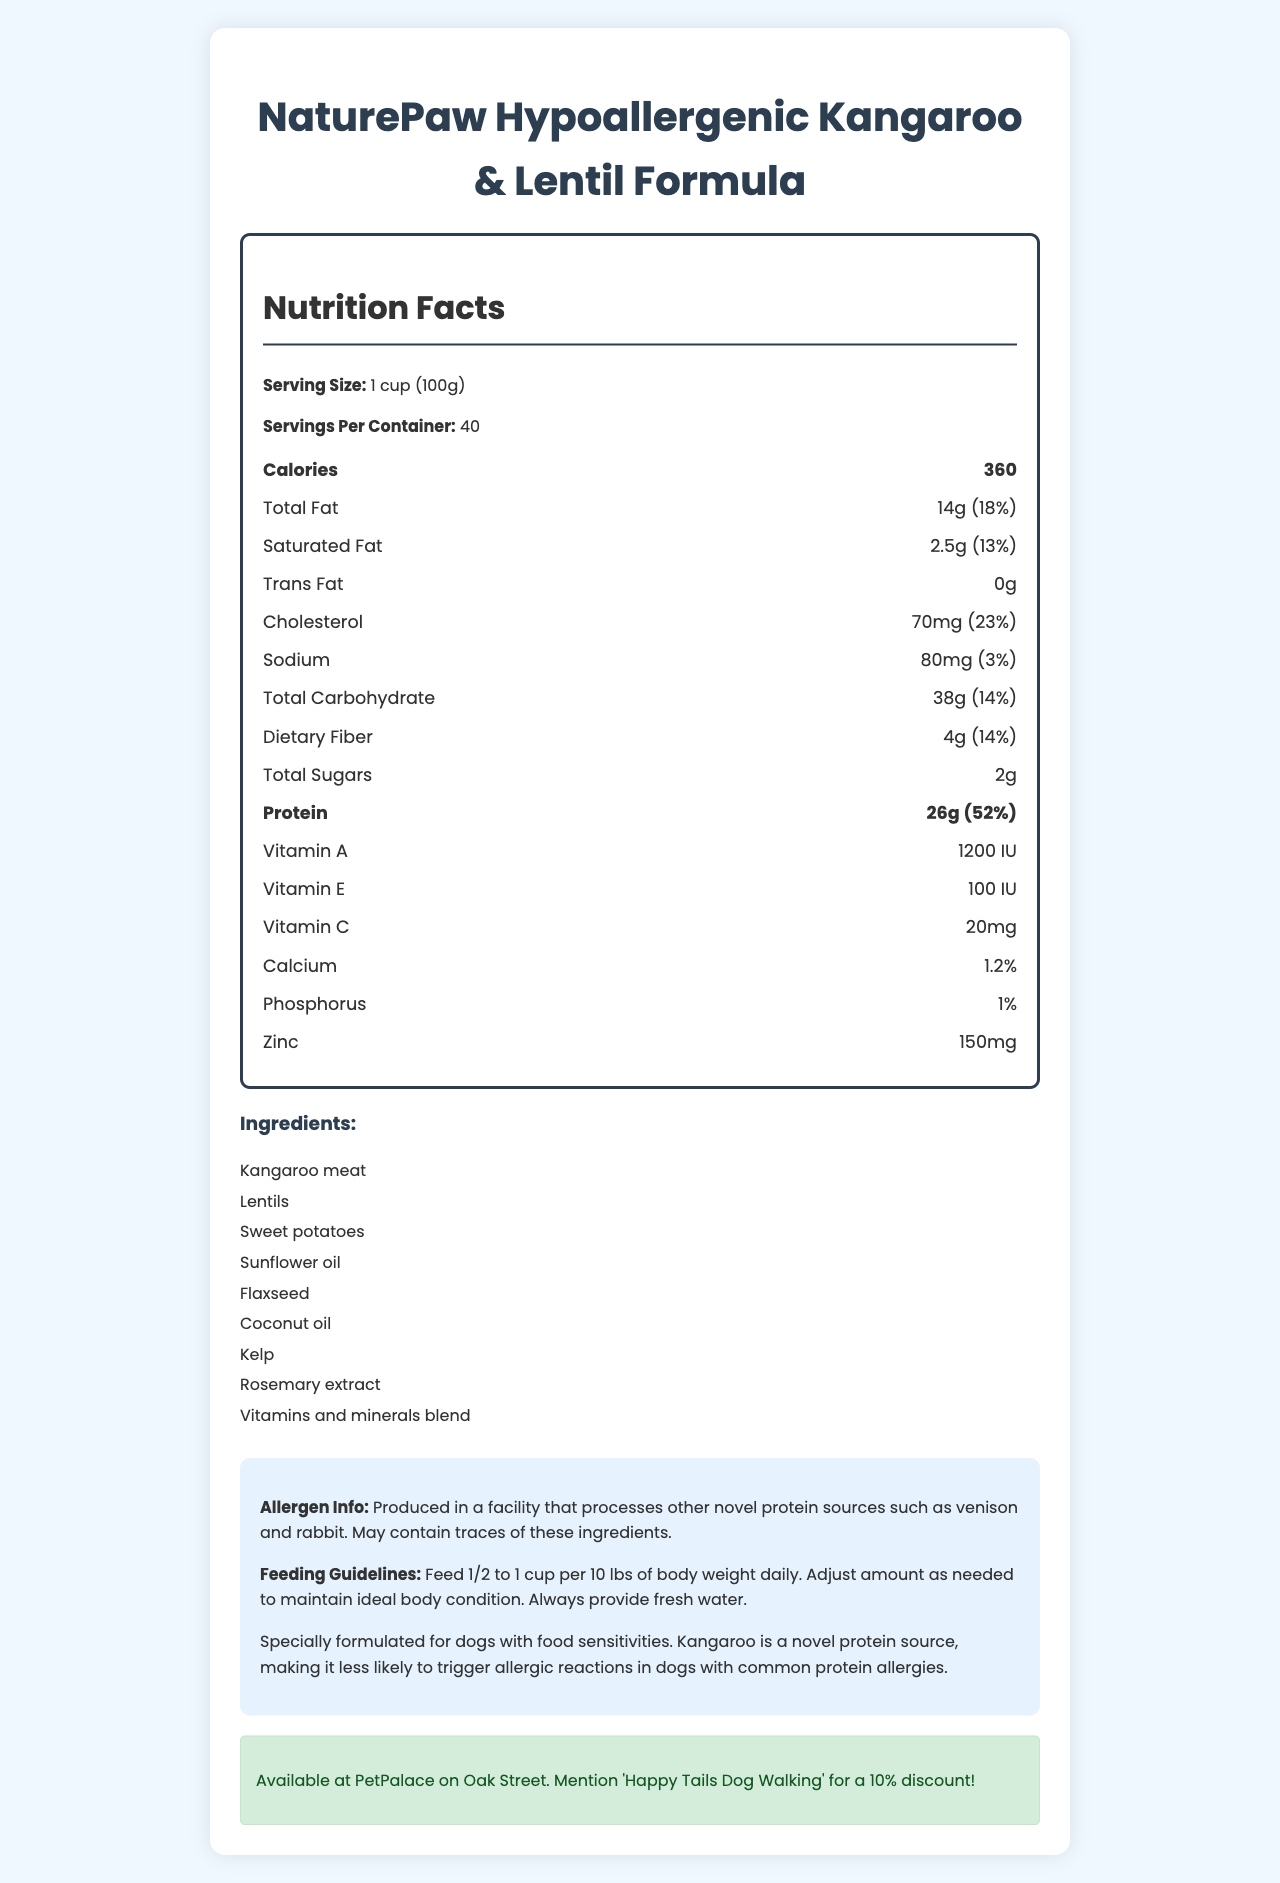what is the serving size for the dog food? The serving size is stated at the top of the nutrition facts section as "1 cup (100g)".
Answer: 1 cup (100g) how many servings are there in a container? The number of servings per container is indicated as 40, right below the serving size.
Answer: 40 how many calories are in one serving? The calorie count per serving is listed as "360" in the bolded section for calories.
Answer: 360 what is the amount of protein in one serving? The amount of protein per serving is listed as 26g in the nutrition facts.
Answer: 26g what are the main ingredients of the dog food? The main ingredients are listed under the ingredient section as: Kangaroo meat, Lentils, Sweet potatoes, Sunflower oil, Flaxseed, Coconut oil, Kelp, Rosemary extract, Vitamins and minerals blend.
Answer: Kangaroo meat, Lentils, Sweet potatoes, Sunflower oil, Flaxseed, Coconut oil, Kelp, Rosemary extract, Vitamins and minerals blend which vitamin is present in the highest amount? A. Vitamin A B. Vitamin C C. Vitamin E The visual information shows that Vitamin E is listed as 100 IU, which is higher than 1200 IU (Vitamin A) and 20mg (Vitamin C).
Answer: C. Vitamin E what percentage of daily value does the total fat represent? A. 10% B. 13% C. 18% D. 23% The total fat daily value is listed as 18%, which can be found next to 14g of total fat.
Answer: C. 18% are there any trans fats in the dog food? The nutrition label states "Trans Fat 0g", indicating there are no trans fats in the food.
Answer: No is the food suitable for dogs with common protein allergies? The additional information section states that it is specially formulated for dogs with food sensitivities and that kangaroo is a novel protein source, making it less likely to trigger allergic reactions in dogs with common protein allergies.
Answer: Yes summarize the overall information provided in the document. The document provides comprehensive nutritional details, ingredients, and feeding guidelines for the hypoallergenic dog food. It emphasizes its suitability for dogs with allergies and offers a discount at a specific pet shop.
Answer: The document is a nutrition facts label for NaturePaw Hypoallergenic Kangaroo & Lentil Formula dog food. It lists serving sizes, nutritional content such as calories, fats, cholesterol, protein, and vitamins. It also includes the ingredients, potential allergen information, feeding guidelines, and a shop recommendation. Special highlights mention the food's suitability for dogs with food sensitivities due to the use of novel protein sources like kangaroo. how much cholesterol is in one serving? The cholesterol content per serving is listed as 70mg.
Answer: 70mg what is the feeding recommendation for a dog weighing 20 lbs? Based on the feeding guidelines, the recommended amount is 1/2 to 1 cup per 10 lbs of body weight. Therefore, for a 20 lb dog, it would be 1 to 2 cups daily.
Answer: 1 to 2 cups daily where can you buy this dog food and get a discount? The document states that the dog food is available at PetPalace on Oak Street, with a 10% discount if you mention "Happy Tails Dog Walking".
Answer: PetPalace on Oak Street how often should fresh water be provided? The feeding guidelines clearly state to always provide fresh water.
Answer: Always provide fresh water what is the daily value percentage for dietary fiber? The daily value percentage for dietary fiber is listed as 14%.
Answer: 14% what type of oil is included in the ingredients? A. Olive oil B. Sunflower oil C. Canola oil The ingredients list includes sunflower oil.
Answer: B. Sunflower oil what wild game protein is used in this dog food? The main protein source listed in the ingredients is kangaroo meat.
Answer: Kangaroo meat what is the total carbohydrate content per serving? The total carbohydrate content per serving is listed as 38g.
Answer: 38g is this dog food specifically made for cats as well? The document only mentions that the food is formulated for dogs with food sensitivities and there is no information about its suitability for cats.
Answer: Not enough information 